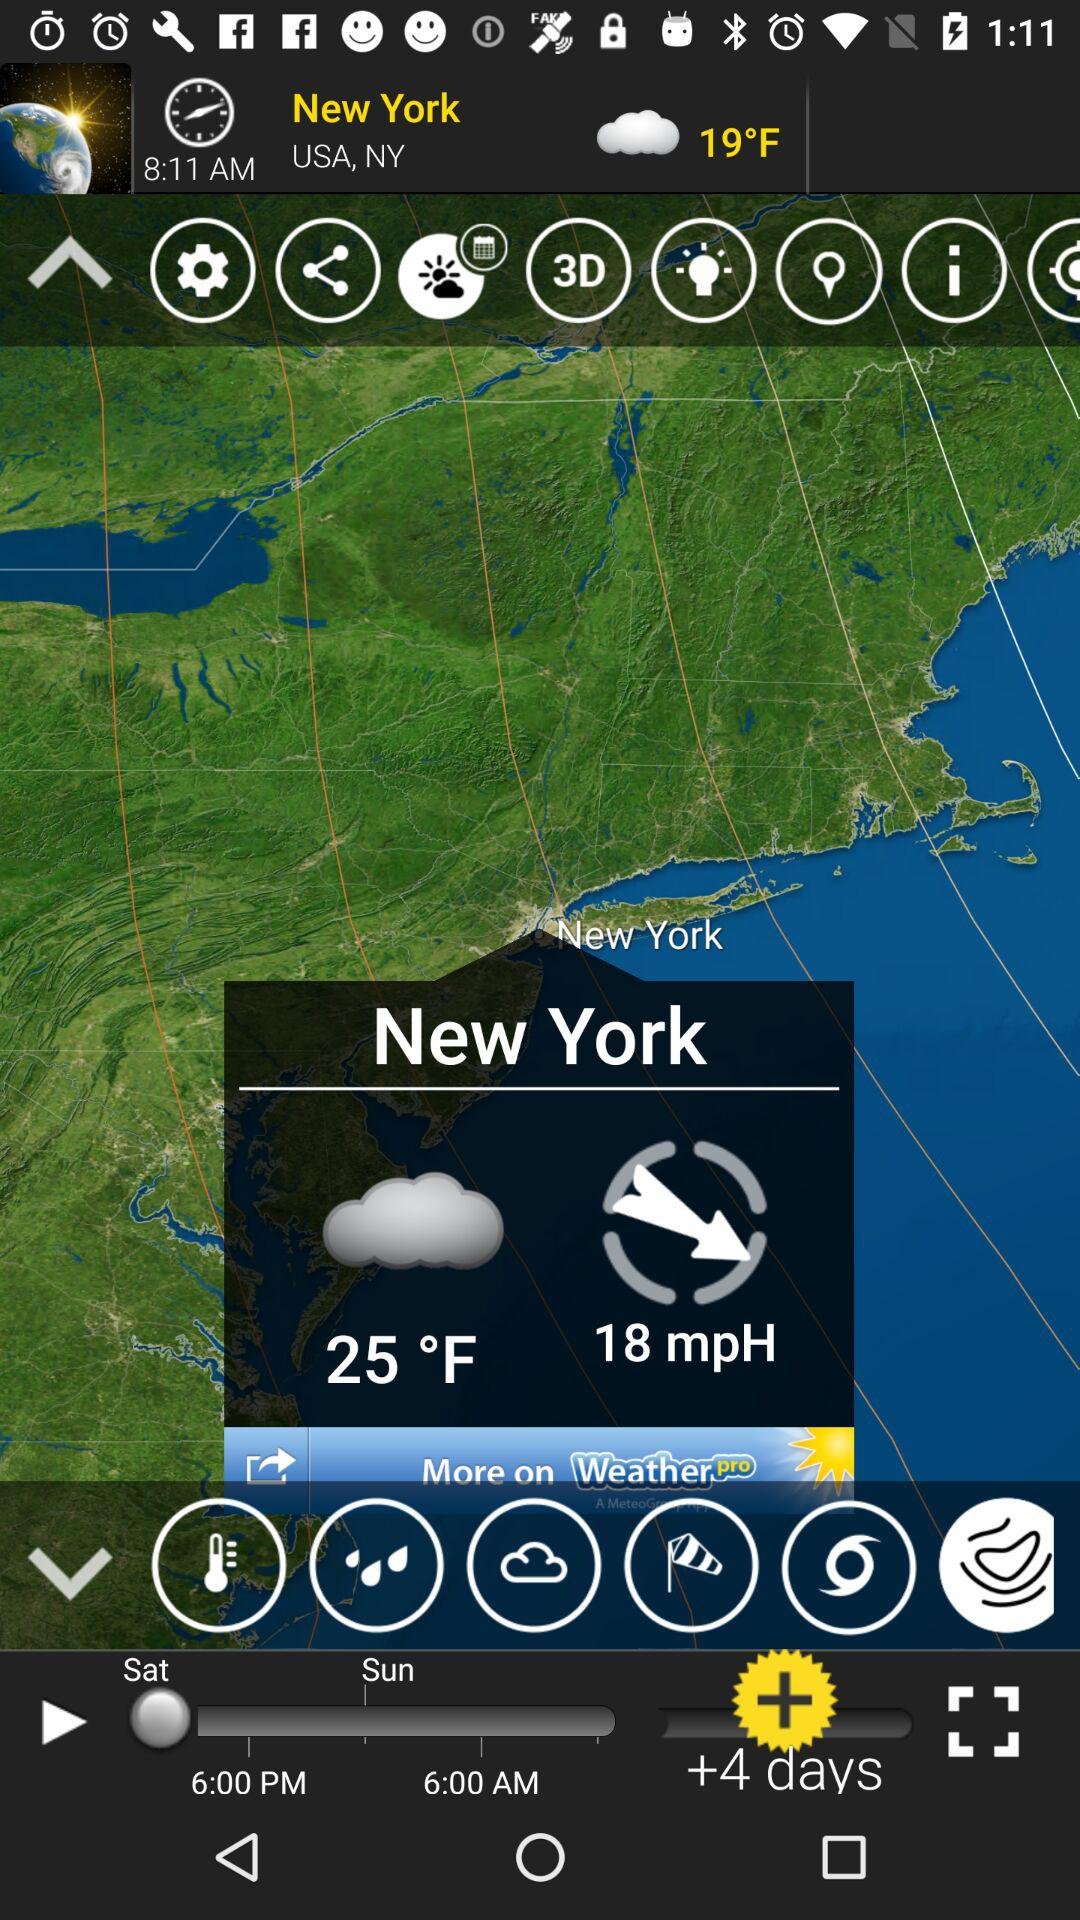What is the temperature? The temperature is 25° F. 